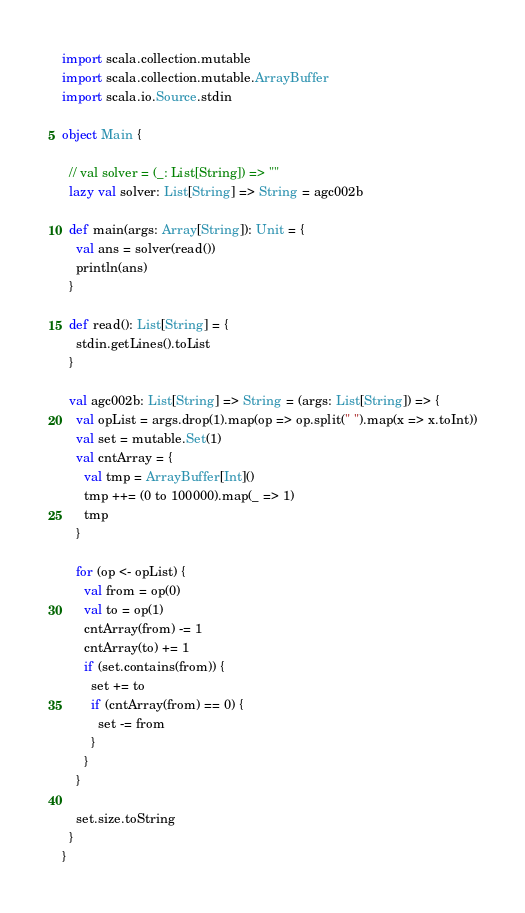<code> <loc_0><loc_0><loc_500><loc_500><_Scala_>import scala.collection.mutable
import scala.collection.mutable.ArrayBuffer
import scala.io.Source.stdin

object Main {

  // val solver = (_: List[String]) => ""
  lazy val solver: List[String] => String = agc002b

  def main(args: Array[String]): Unit = {
    val ans = solver(read())
    println(ans)
  }

  def read(): List[String] = {
    stdin.getLines().toList
  }

  val agc002b: List[String] => String = (args: List[String]) => {
    val opList = args.drop(1).map(op => op.split(" ").map(x => x.toInt))
    val set = mutable.Set(1)
    val cntArray = {
      val tmp = ArrayBuffer[Int]()
      tmp ++= (0 to 100000).map(_ => 1)
      tmp
    }

    for (op <- opList) {
      val from = op(0)
      val to = op(1)
      cntArray(from) -= 1
      cntArray(to) += 1
      if (set.contains(from)) {
        set += to
        if (cntArray(from) == 0) {
          set -= from
        }
      }
    }

    set.size.toString
  }
}
</code> 